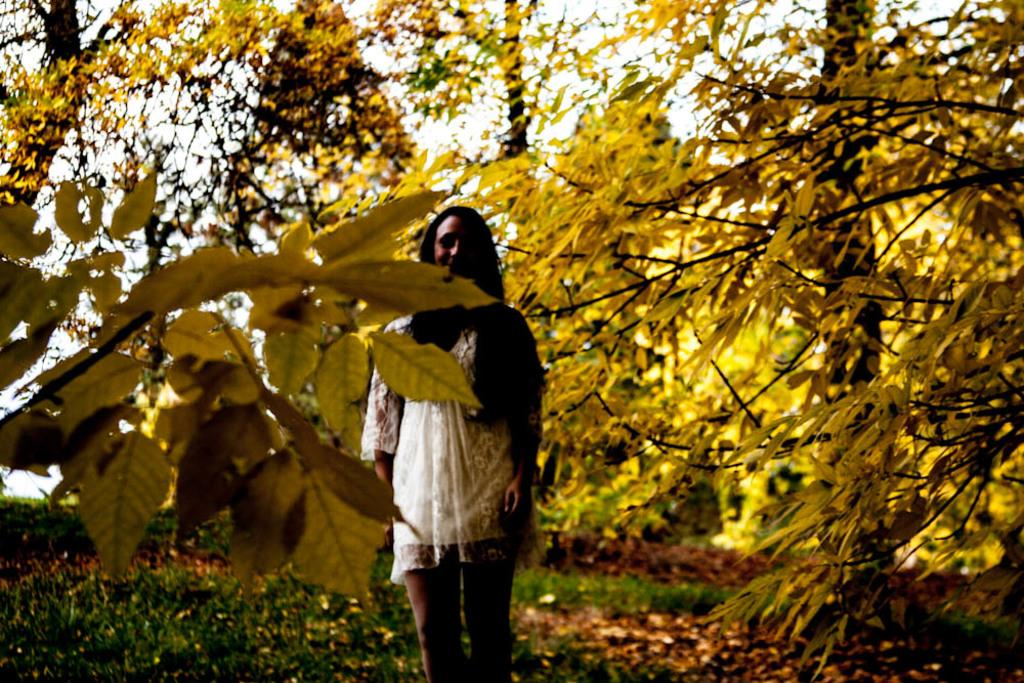Who is present in the image? There is a woman in the image. What is the woman's expression? The woman is smiling. What type of vegetation can be seen in the image? There are plants, dried leaves, and trees in the image. What can be seen in the background of the image? The sky is visible in the background of the image. What type of thing is the woman using to embark on her voyage in the image? There is no indication of a voyage or any object related to a voyage in the image. 